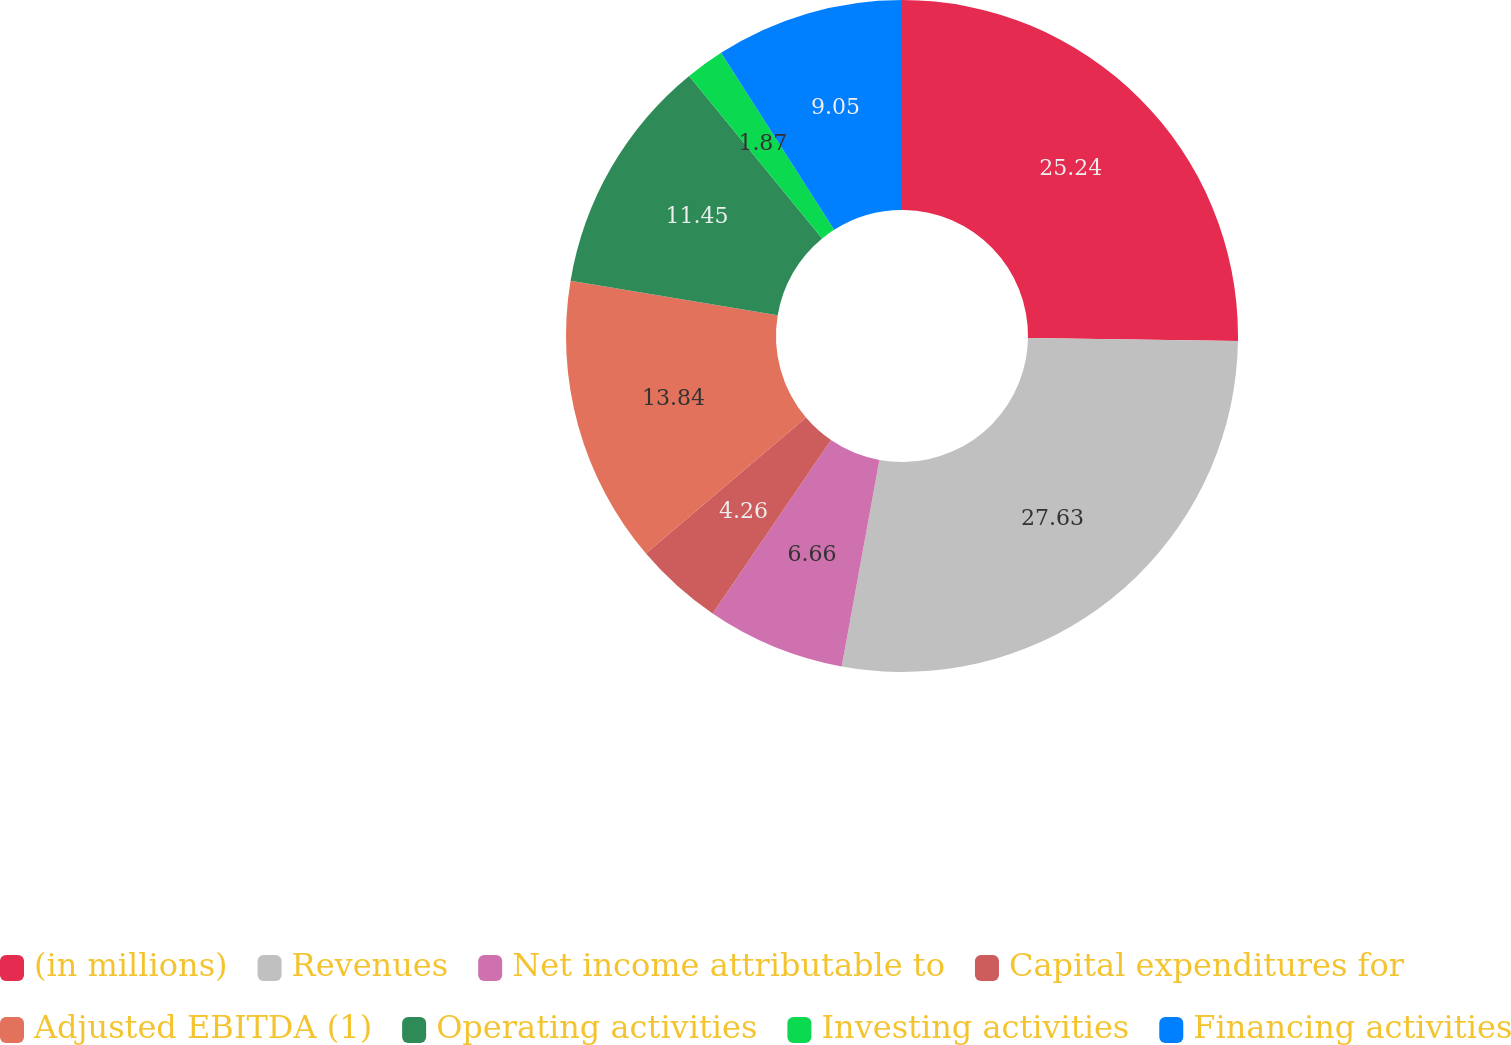Convert chart to OTSL. <chart><loc_0><loc_0><loc_500><loc_500><pie_chart><fcel>(in millions)<fcel>Revenues<fcel>Net income attributable to<fcel>Capital expenditures for<fcel>Adjusted EBITDA (1)<fcel>Operating activities<fcel>Investing activities<fcel>Financing activities<nl><fcel>25.24%<fcel>27.63%<fcel>6.66%<fcel>4.26%<fcel>13.84%<fcel>11.45%<fcel>1.87%<fcel>9.05%<nl></chart> 